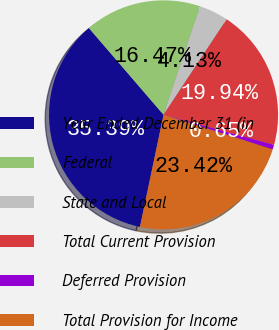Convert chart. <chart><loc_0><loc_0><loc_500><loc_500><pie_chart><fcel>Year Ended December 31 (in<fcel>Federal<fcel>State and Local<fcel>Total Current Provision<fcel>Deferred Provision<fcel>Total Provision for Income<nl><fcel>35.39%<fcel>16.47%<fcel>4.13%<fcel>19.94%<fcel>0.65%<fcel>23.42%<nl></chart> 